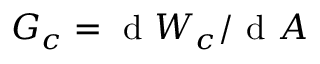Convert formula to latex. <formula><loc_0><loc_0><loc_500><loc_500>G _ { c } = d W _ { c } / d A</formula> 